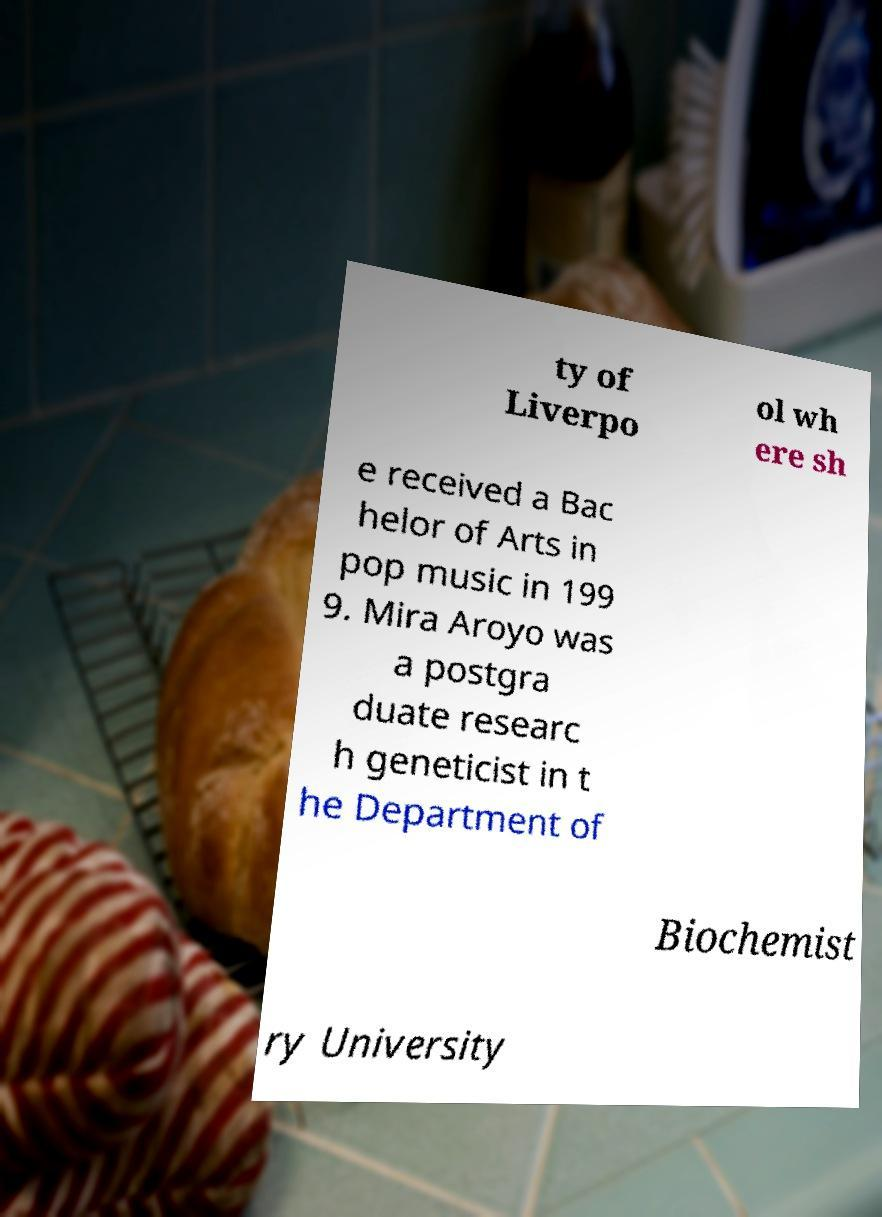For documentation purposes, I need the text within this image transcribed. Could you provide that? ty of Liverpo ol wh ere sh e received a Bac helor of Arts in pop music in 199 9. Mira Aroyo was a postgra duate researc h geneticist in t he Department of Biochemist ry University 